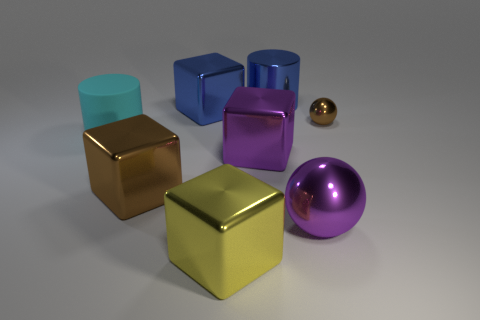Add 1 big purple objects. How many objects exist? 9 Subtract all balls. How many objects are left? 6 Subtract 0 gray cylinders. How many objects are left? 8 Subtract all tiny metal spheres. Subtract all shiny blocks. How many objects are left? 3 Add 4 tiny brown balls. How many tiny brown balls are left? 5 Add 2 big metallic cylinders. How many big metallic cylinders exist? 3 